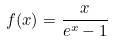<formula> <loc_0><loc_0><loc_500><loc_500>f ( x ) = \frac { x } { e ^ { x } - 1 }</formula> 